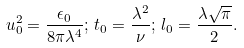Convert formula to latex. <formula><loc_0><loc_0><loc_500><loc_500>u _ { 0 } ^ { 2 } = \frac { \epsilon _ { 0 } } { 8 \pi \lambda ^ { 4 } } ; \, t _ { 0 } = \frac { \lambda ^ { 2 } } \nu ; \, l _ { 0 } = \frac { \lambda \sqrt { \pi } } 2 .</formula> 